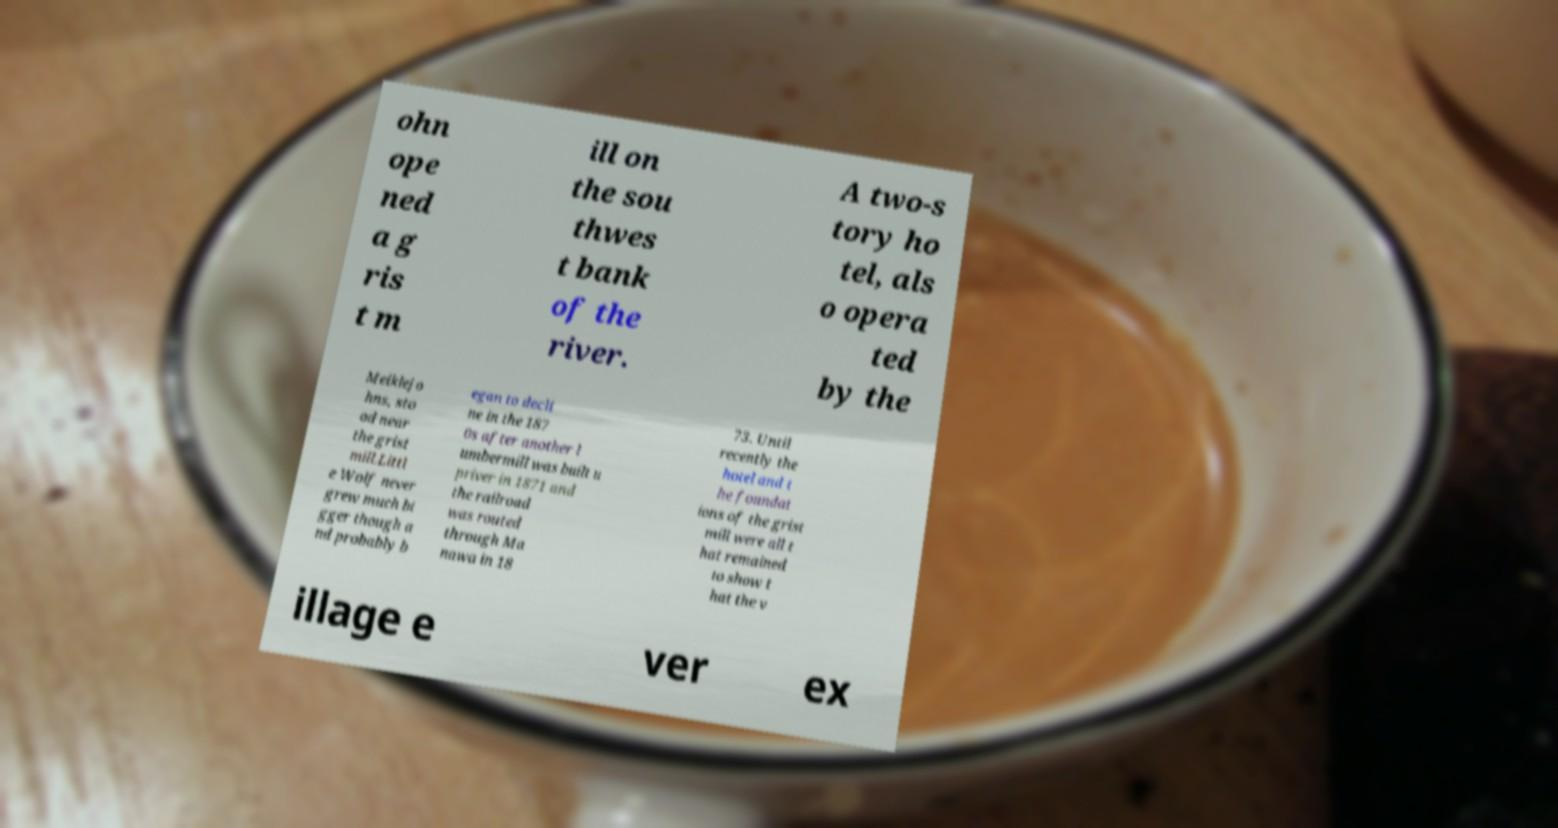Please identify and transcribe the text found in this image. ohn ope ned a g ris t m ill on the sou thwes t bank of the river. A two-s tory ho tel, als o opera ted by the Meiklejo hns, sto od near the grist mill.Littl e Wolf never grew much bi gger though a nd probably b egan to decli ne in the 187 0s after another l umbermill was built u priver in 1871 and the railroad was routed through Ma nawa in 18 73. Until recently the hotel and t he foundat ions of the grist mill were all t hat remained to show t hat the v illage e ver ex 